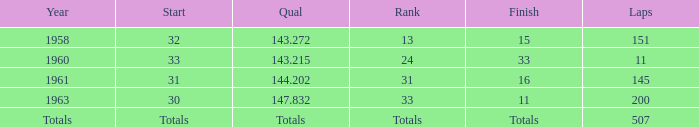What year was the conclusion of 15 witnessed in? 1958.0. 